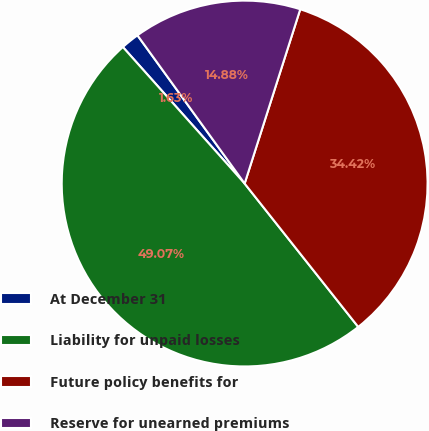Convert chart to OTSL. <chart><loc_0><loc_0><loc_500><loc_500><pie_chart><fcel>At December 31<fcel>Liability for unpaid losses<fcel>Future policy benefits for<fcel>Reserve for unearned premiums<nl><fcel>1.63%<fcel>49.07%<fcel>34.42%<fcel>14.88%<nl></chart> 